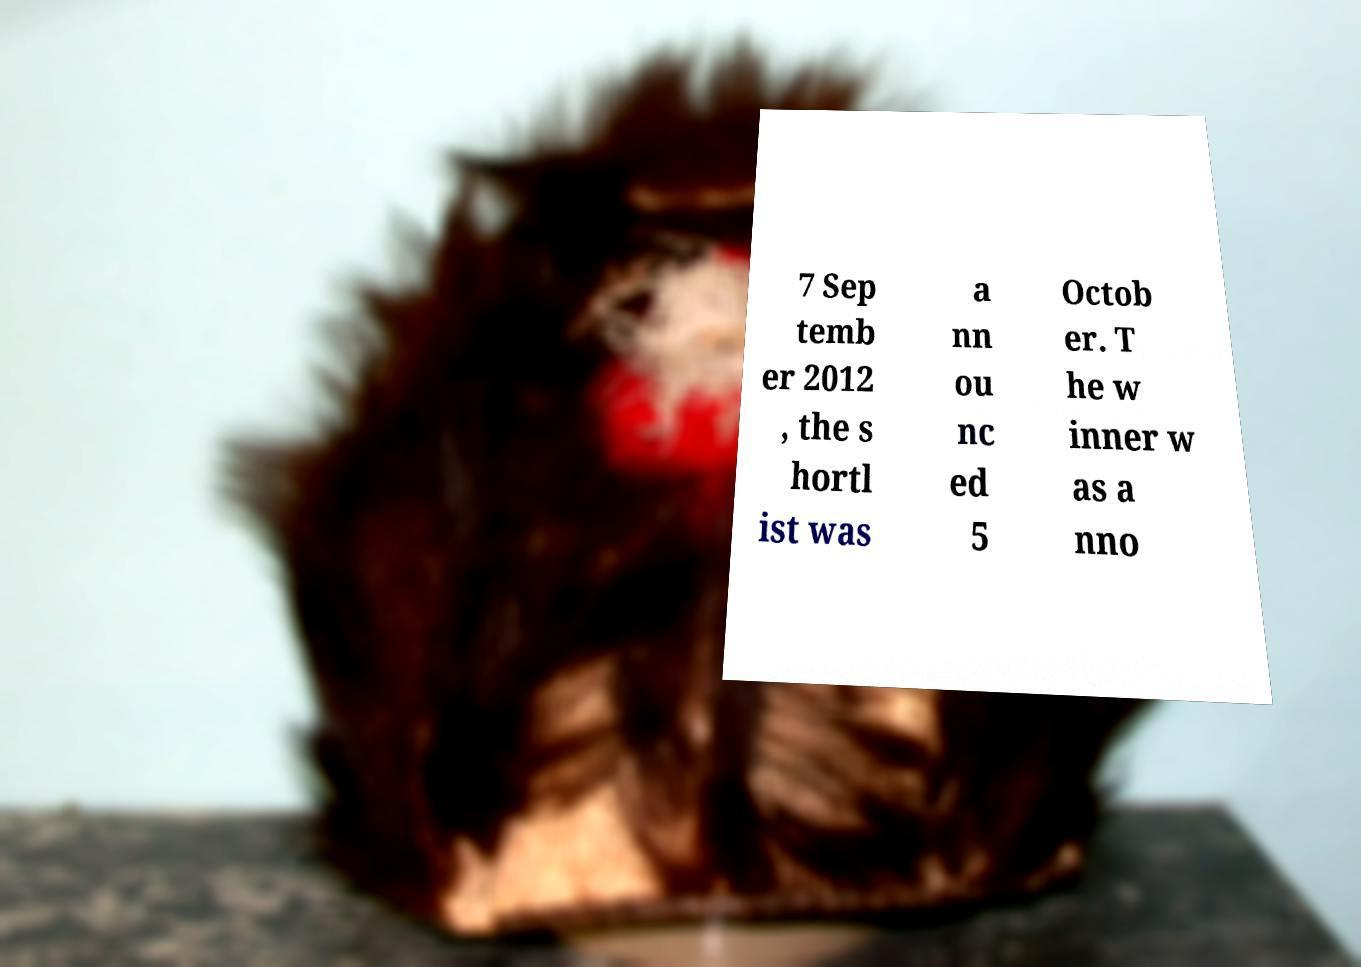Please identify and transcribe the text found in this image. 7 Sep temb er 2012 , the s hortl ist was a nn ou nc ed 5 Octob er. T he w inner w as a nno 